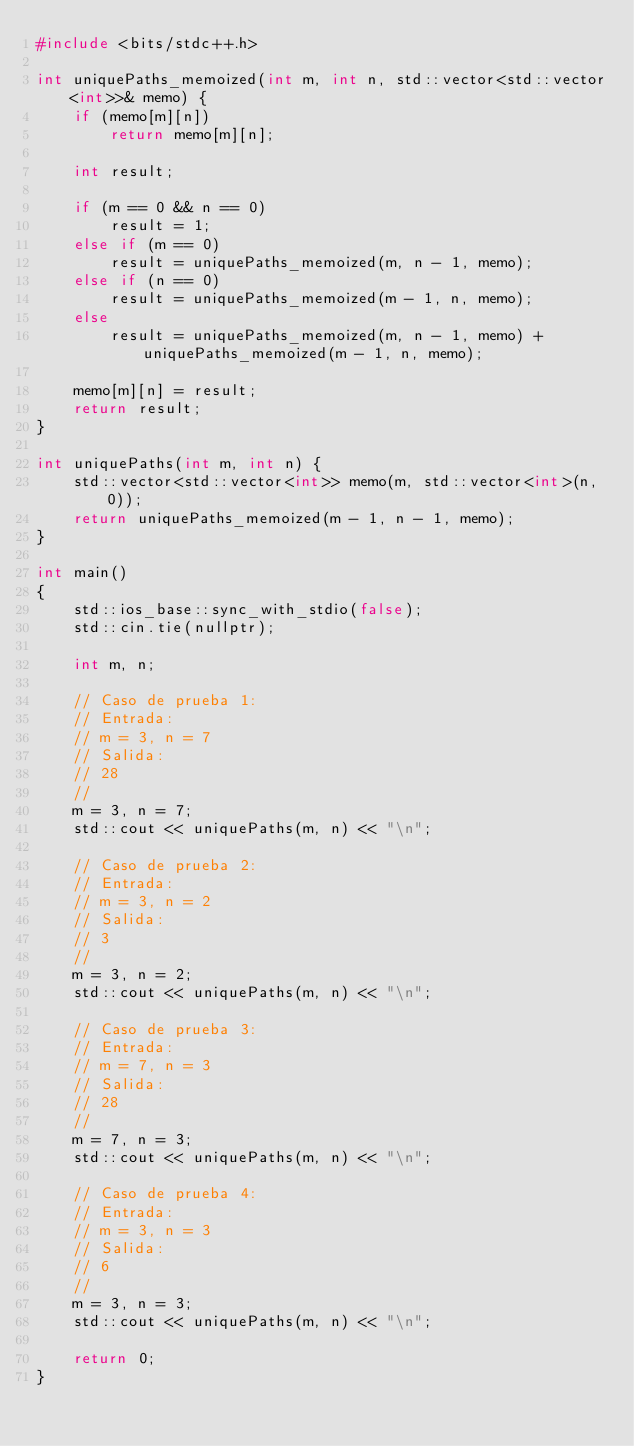Convert code to text. <code><loc_0><loc_0><loc_500><loc_500><_C++_>#include <bits/stdc++.h>

int uniquePaths_memoized(int m, int n, std::vector<std::vector<int>>& memo) {
	if (memo[m][n])
		return memo[m][n];

	int result;

	if (m == 0 && n == 0)
		result = 1;
	else if (m == 0)
		result = uniquePaths_memoized(m, n - 1, memo);
	else if (n == 0)
		result = uniquePaths_memoized(m - 1, n, memo);
	else
		result = uniquePaths_memoized(m, n - 1, memo) + uniquePaths_memoized(m - 1, n, memo);

	memo[m][n] = result;
	return result;
}

int uniquePaths(int m, int n) {
	std::vector<std::vector<int>> memo(m, std::vector<int>(n, 0));
	return uniquePaths_memoized(m - 1, n - 1, memo);
}

int main()
{
	std::ios_base::sync_with_stdio(false);
	std::cin.tie(nullptr);

	int m, n;

	// Caso de prueba 1:
	// Entrada:
	// m = 3, n = 7
	// Salida:
	// 28
	//
	m = 3, n = 7;
	std::cout << uniquePaths(m, n) << "\n";

	// Caso de prueba 2:
	// Entrada:
	// m = 3, n = 2
	// Salida:
	// 3
	//
	m = 3, n = 2;
	std::cout << uniquePaths(m, n) << "\n";

	// Caso de prueba 3:
	// Entrada:
	// m = 7, n = 3
	// Salida:
	// 28
	//
	m = 7, n = 3;
	std::cout << uniquePaths(m, n) << "\n";

	// Caso de prueba 4:
	// Entrada:
	// m = 3, n = 3
	// Salida:
	// 6
	//
	m = 3, n = 3;
	std::cout << uniquePaths(m, n) << "\n";

	return 0;
}
</code> 